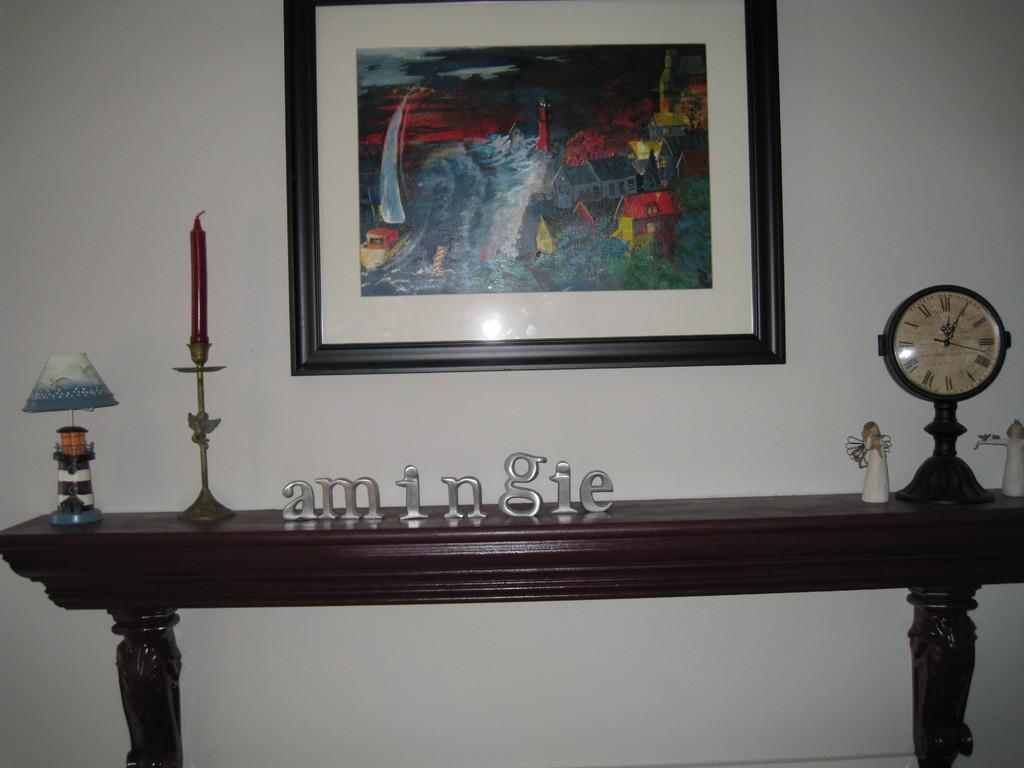What is present on the wall in the image? There is a photo frame, a candle with a stand, and a watch on the wall in the image. Can you describe the photo frame on the wall? The photo frame is a rectangular frame that likely holds a picture or artwork. What is the purpose of the candle with a stand on the wall? The candle with a stand on the wall may serve as a decorative or functional item, providing light or ambiance. What is the watch on the wall used for? The watch on the wall is likely used for keeping track of time. What is written on the table in the image? The word "amingie" is written on a table in the image. How many toes are visible in the image? There are no toes visible in the image. What type of event is taking place in the image? There is no event taking place in the image; it is a still scene featuring a wall with various items. 